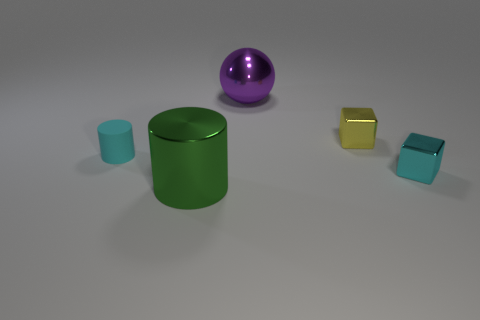Add 1 green spheres. How many objects exist? 6 Subtract all cylinders. How many objects are left? 3 Subtract all tiny rubber things. Subtract all cylinders. How many objects are left? 2 Add 2 matte cylinders. How many matte cylinders are left? 3 Add 4 tiny cyan cubes. How many tiny cyan cubes exist? 5 Subtract 0 purple blocks. How many objects are left? 5 